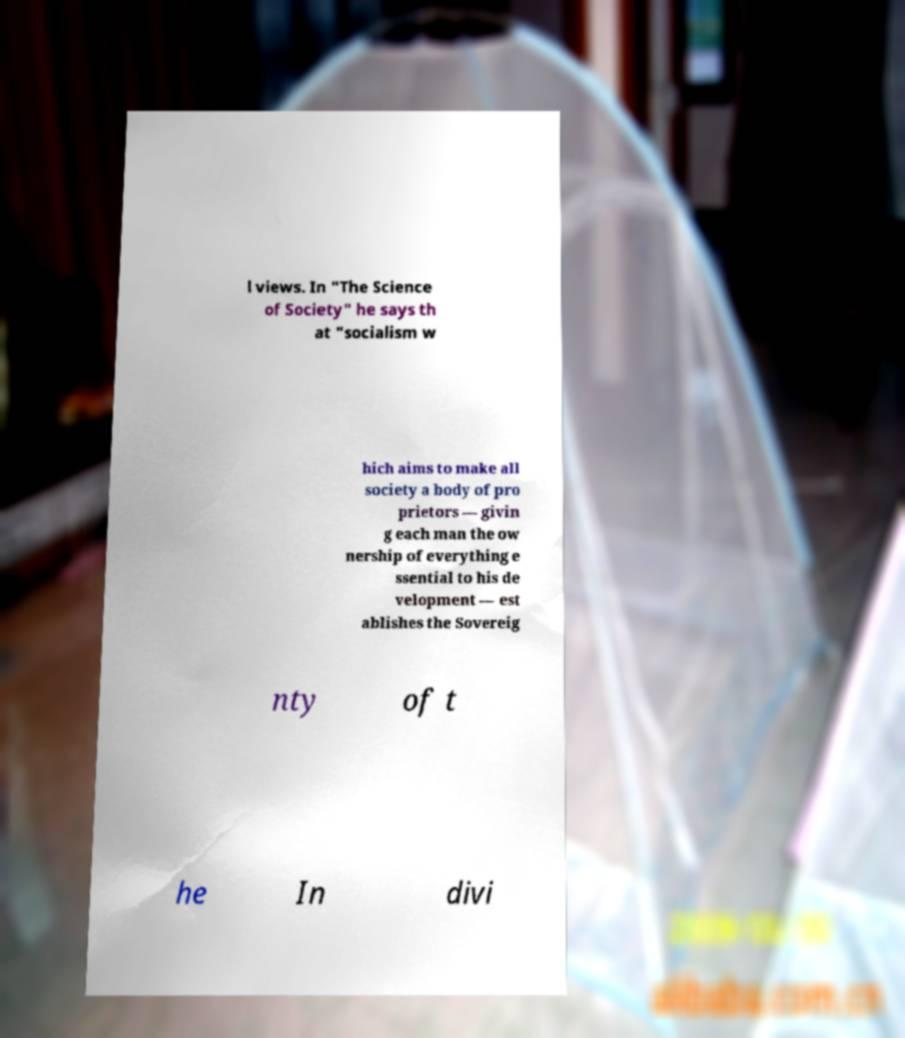I need the written content from this picture converted into text. Can you do that? l views. In "The Science of Society" he says th at "socialism w hich aims to make all society a body of pro prietors — givin g each man the ow nership of everything e ssential to his de velopment — est ablishes the Sovereig nty of t he In divi 